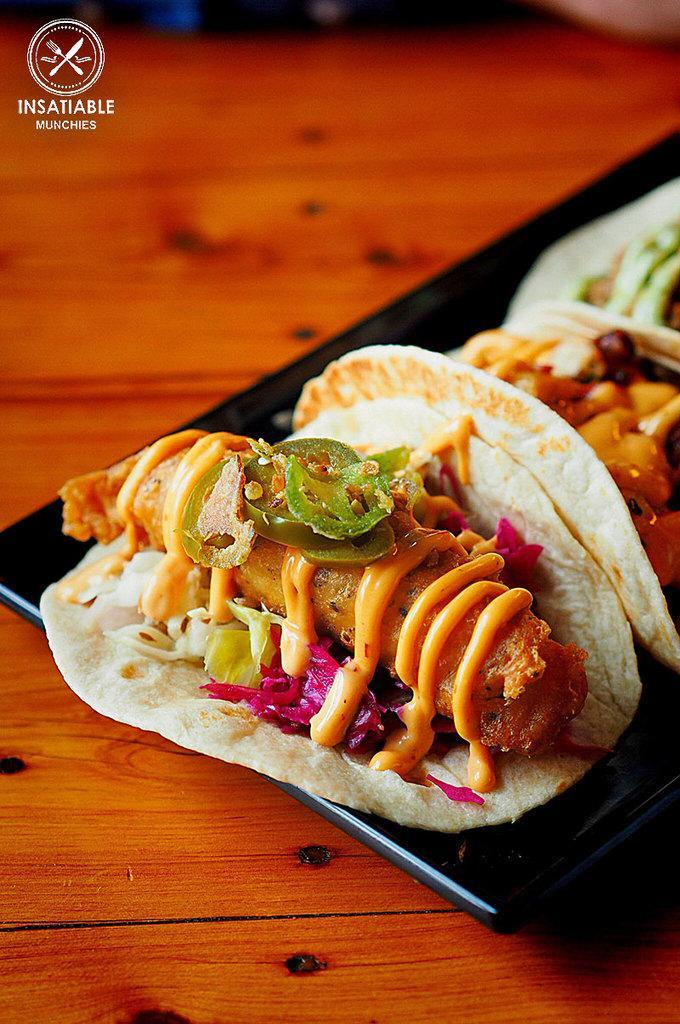How would you summarize this image in a sentence or two? In this picture I can see food items on the plate, on the table, and there is a watermark on the image. 